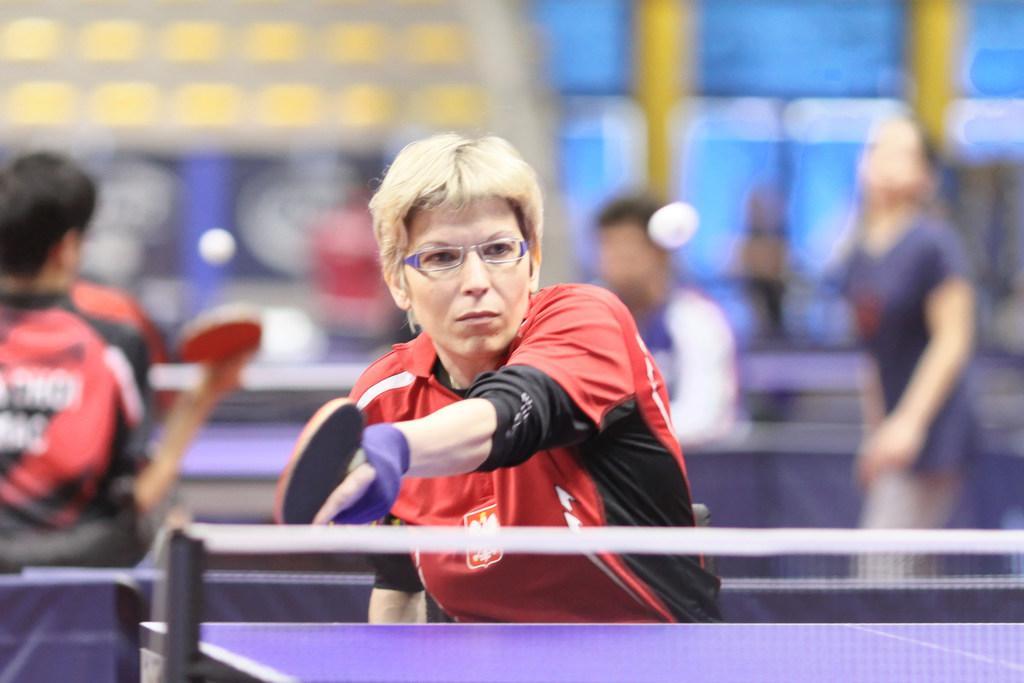How would you summarize this image in a sentence or two? In this picture I can see few people playing table tennis and I can see blurry background. 